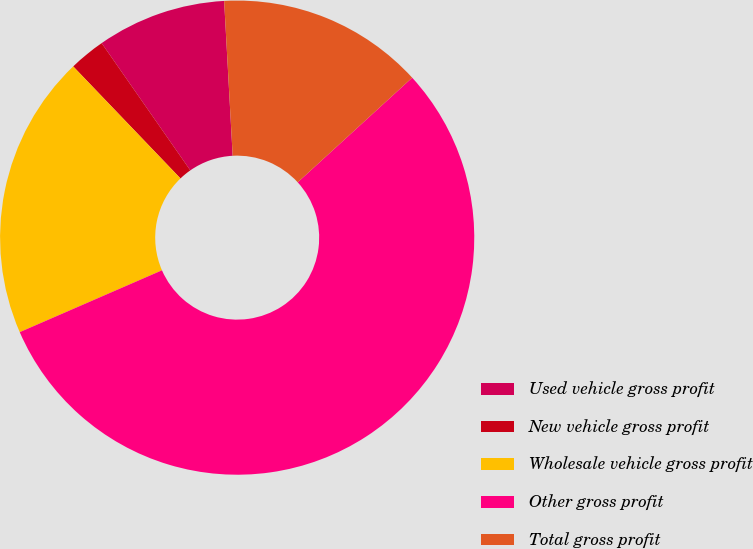Convert chart. <chart><loc_0><loc_0><loc_500><loc_500><pie_chart><fcel>Used vehicle gross profit<fcel>New vehicle gross profit<fcel>Wholesale vehicle gross profit<fcel>Other gross profit<fcel>Total gross profit<nl><fcel>8.81%<fcel>2.47%<fcel>19.37%<fcel>55.26%<fcel>14.09%<nl></chart> 